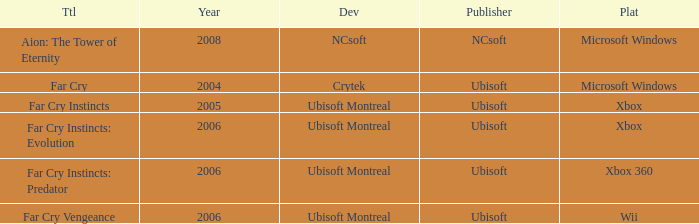Which developer utilizes xbox 360 as their platform? Ubisoft Montreal. 